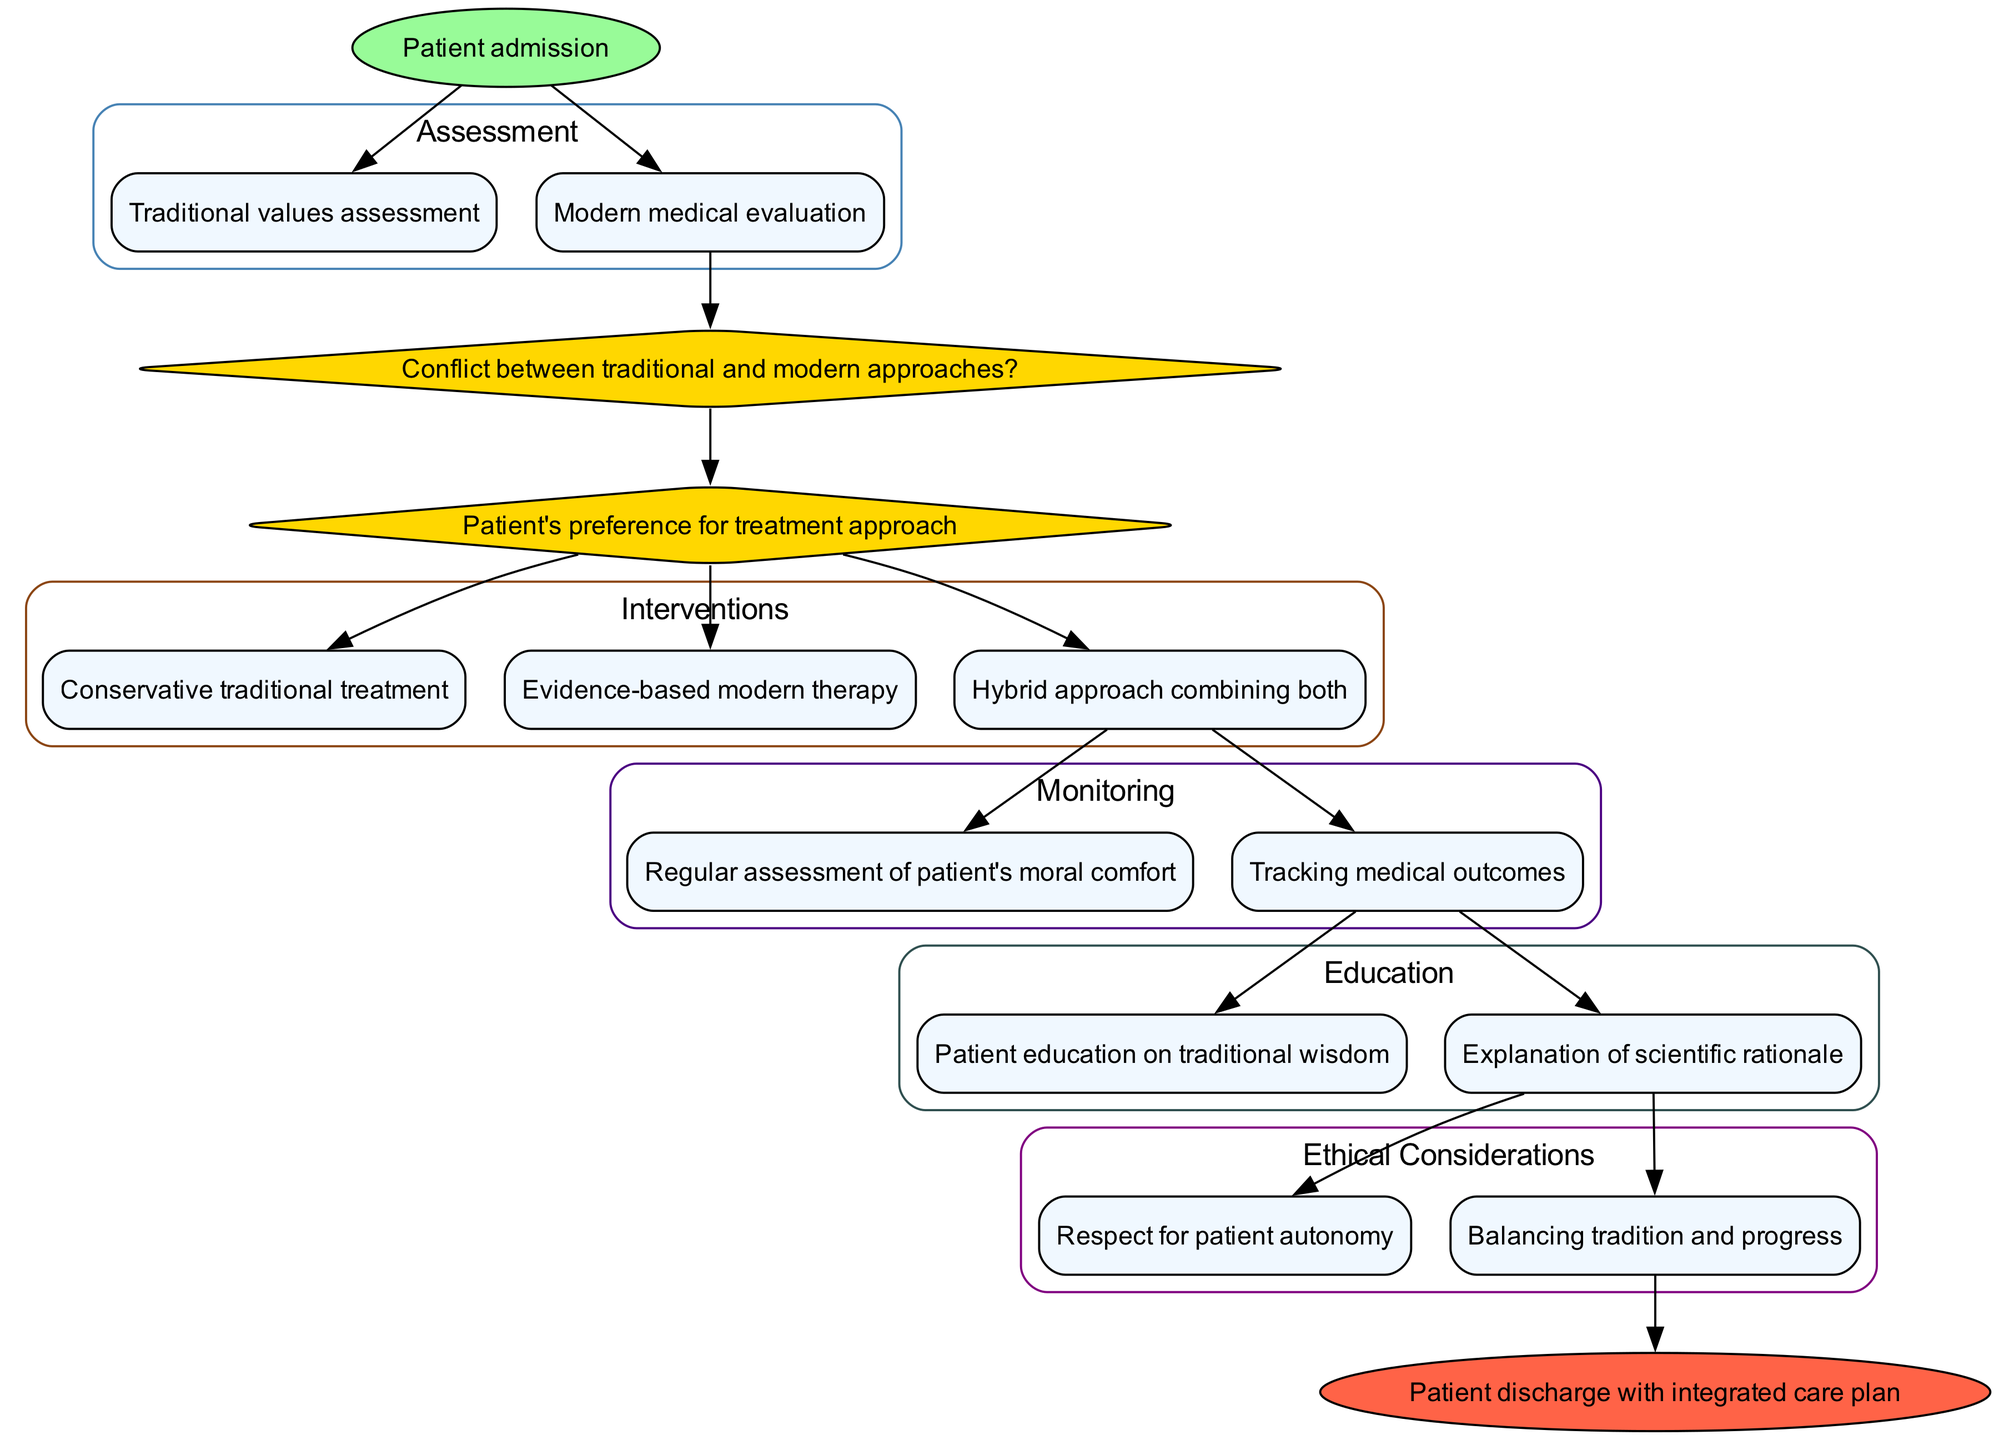What is the starting point of the clinical pathway? The diagram indicates that the first step of the pathway is "Patient admission."
Answer: Patient admission How many assessment nodes are in the diagram? There are two assessment nodes: "Traditional values assessment" and "Modern medical evaluation."
Answer: 2 What is the first decision point in the clinical pathway? The first decision point is "Conflict between traditional and modern approaches?" as it is the initial choice following assessments.
Answer: Conflict between traditional and modern approaches? What intervention follows the last decision point? The last decision point leads to three possible interventions, but specifically, all interventions follow the final decision point, thus the first listed is "Conservative traditional treatment."
Answer: Conservative traditional treatment What type of node signifies a monitoring phase? The diagram uses a rounded rectangle node to denote the monitoring phase, specifically highlighting "Regular assessment of patient's moral comfort" and "Tracking medical outcomes."
Answer: Rounded rectangle How many different types of education are provided in the pathway? There are two types of education outlined: "Patient education on traditional wisdom" and "Explanation of scientific rationale."
Answer: 2 Which ethical consideration emphasizes patient rights? The ethical consideration that emphasizes patient rights is "Respect for patient autonomy," as it directly addresses the patient's decision-making rights.
Answer: Respect for patient autonomy What is the end point of the clinical pathway? The pathway concludes with the end node labeled "Patient discharge with integrated care plan."
Answer: Patient discharge with integrated care plan Which intervention combines both traditional and modern approaches? The intervention that combines both approaches is identified as "Hybrid approach combining both," which suggests a blending of treatment philosophies.
Answer: Hybrid approach combining both 